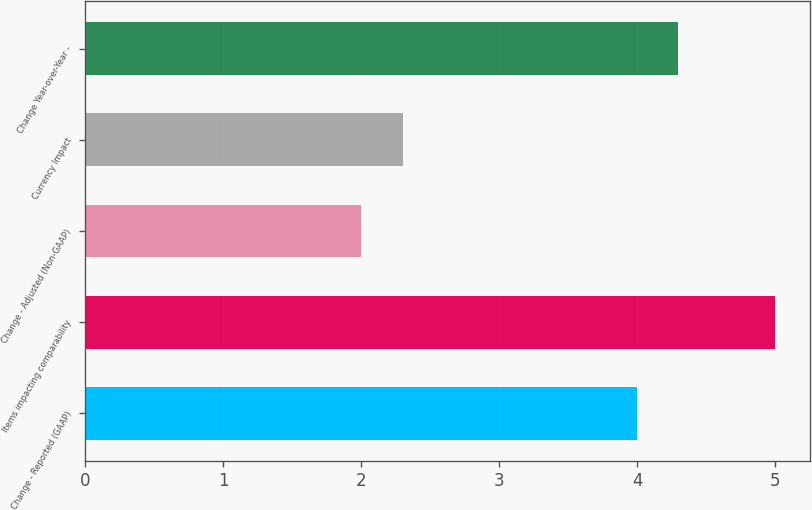Convert chart. <chart><loc_0><loc_0><loc_500><loc_500><bar_chart><fcel>Change - Reported (GAAP)<fcel>Items impacting comparability<fcel>Change - Adjusted (Non-GAAP)<fcel>Currency Impact<fcel>Change Year-over-Year -<nl><fcel>4<fcel>5<fcel>2<fcel>2.3<fcel>4.3<nl></chart> 